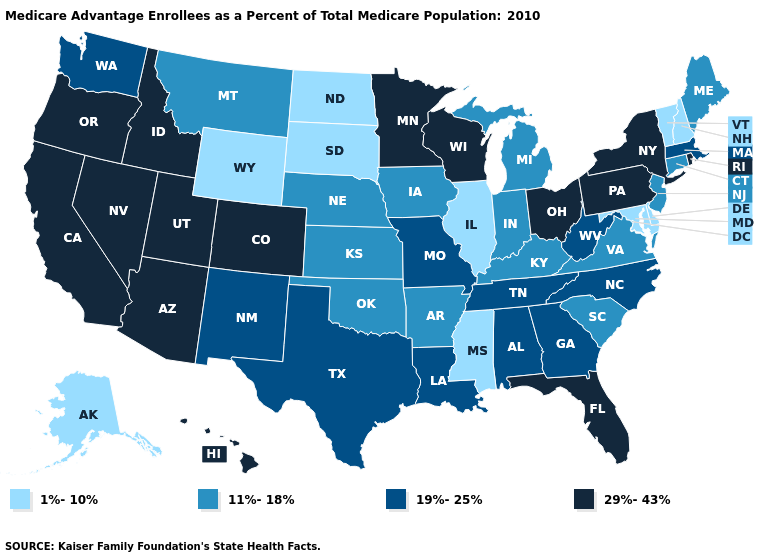What is the highest value in the South ?
Be succinct. 29%-43%. Does the map have missing data?
Answer briefly. No. Which states have the lowest value in the South?
Write a very short answer. Delaware, Maryland, Mississippi. Is the legend a continuous bar?
Concise answer only. No. What is the value of Alabama?
Short answer required. 19%-25%. Name the states that have a value in the range 19%-25%?
Answer briefly. Alabama, Georgia, Louisiana, Massachusetts, Missouri, North Carolina, New Mexico, Tennessee, Texas, Washington, West Virginia. Does the first symbol in the legend represent the smallest category?
Answer briefly. Yes. What is the highest value in the MidWest ?
Short answer required. 29%-43%. Which states hav the highest value in the West?
Keep it brief. Arizona, California, Colorado, Hawaii, Idaho, Nevada, Oregon, Utah. Which states have the lowest value in the Northeast?
Quick response, please. New Hampshire, Vermont. Does the first symbol in the legend represent the smallest category?
Short answer required. Yes. Name the states that have a value in the range 11%-18%?
Short answer required. Arkansas, Connecticut, Iowa, Indiana, Kansas, Kentucky, Maine, Michigan, Montana, Nebraska, New Jersey, Oklahoma, South Carolina, Virginia. What is the highest value in the USA?
Write a very short answer. 29%-43%. Among the states that border North Dakota , which have the lowest value?
Concise answer only. South Dakota. Among the states that border Virginia , which have the highest value?
Be succinct. North Carolina, Tennessee, West Virginia. 